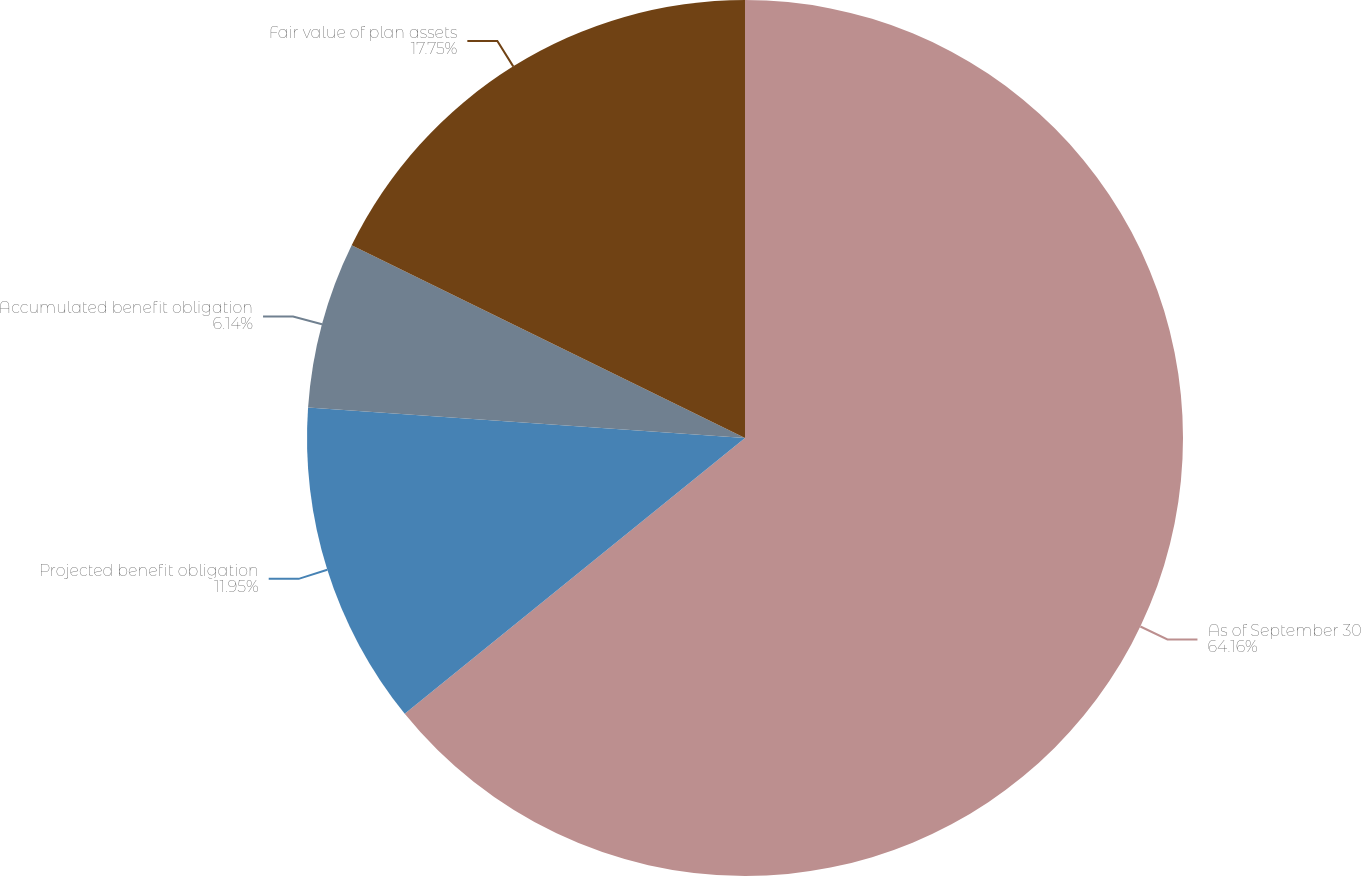<chart> <loc_0><loc_0><loc_500><loc_500><pie_chart><fcel>As of September 30<fcel>Projected benefit obligation<fcel>Accumulated benefit obligation<fcel>Fair value of plan assets<nl><fcel>64.16%<fcel>11.95%<fcel>6.14%<fcel>17.75%<nl></chart> 